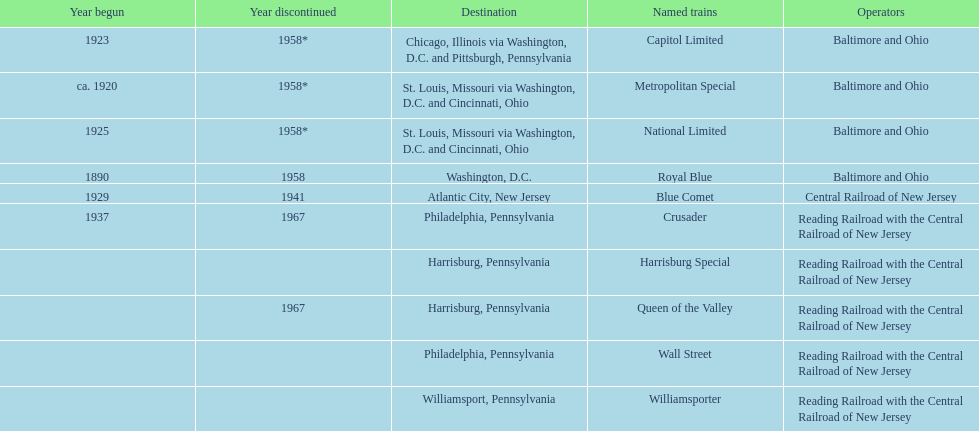What was the first train to begin service? Royal Blue. 